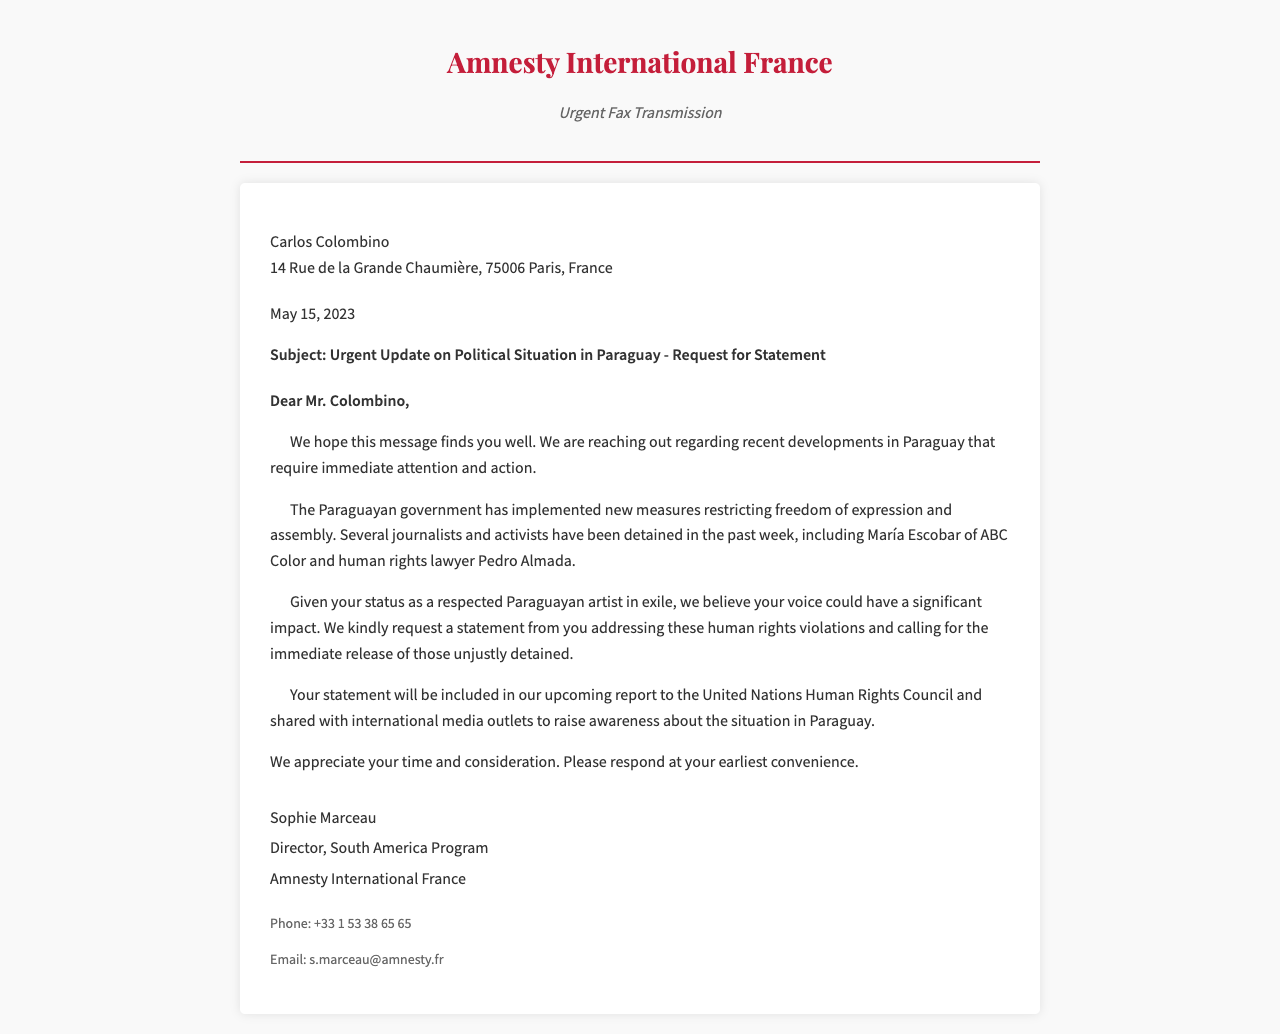What is the organization sending the fax? The fax is sent by Amnesty International France, which is stated in the header of the document.
Answer: Amnesty International France Who is the recipient of the fax? The fax is addressed to Carlos Colombino, as mentioned at the beginning of the document.
Answer: Carlos Colombino What date was the fax sent? The date is mentioned in the document, specifically stating May 15, 2023.
Answer: May 15, 2023 What is the subject of the fax? The subject line reveals the focus of the fax, which is about the political situation in Paraguay and a request for a statement.
Answer: Urgent Update on Political Situation in Paraguay - Request for Statement Who is quoted in the fax stating human rights violations? The document references María Escobar of ABC Color and human rights lawyer Pedro Almada as being detained.
Answer: María Escobar and Pedro Almada What does the organization request from Carlos Colombino? The fax clearly states that they kindly request a statement addressing human rights violations in Paraguay.
Answer: A statement What will happen to the statement provided by the artist? The organization plans to include the statement in their upcoming report to the United Nations Human Rights Council.
Answer: Included in the report What is the closing signature of the fax? The fax is signed off by Sophie Marceau, which is part of the signature section at the end.
Answer: Sophie Marceau What is the phone number provided in the fax? A specific phone number for Amnesty International France is listed in the contact section.
Answer: +33 1 53 38 65 65 